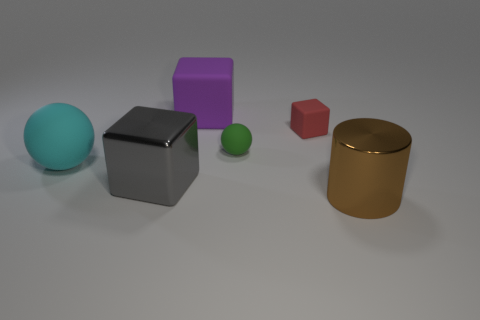Add 3 green matte objects. How many objects exist? 9 Subtract all cylinders. How many objects are left? 5 Subtract all large purple rubber objects. Subtract all big brown metallic balls. How many objects are left? 5 Add 3 tiny rubber blocks. How many tiny rubber blocks are left? 4 Add 1 large green shiny balls. How many large green shiny balls exist? 1 Subtract 0 cyan cylinders. How many objects are left? 6 